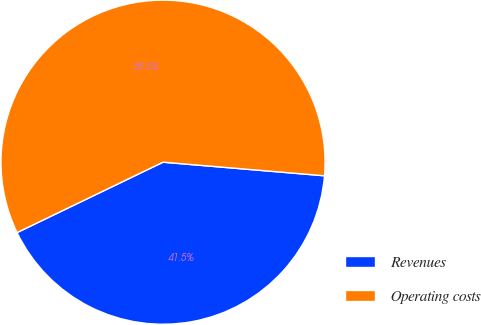Convert chart to OTSL. <chart><loc_0><loc_0><loc_500><loc_500><pie_chart><fcel>Revenues<fcel>Operating costs<nl><fcel>41.51%<fcel>58.49%<nl></chart> 